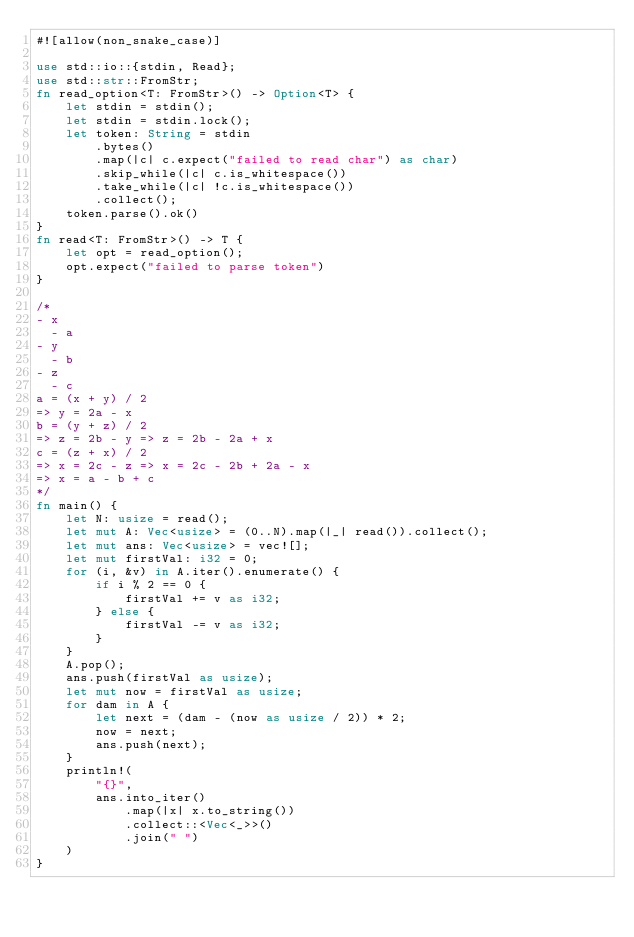<code> <loc_0><loc_0><loc_500><loc_500><_Rust_>#![allow(non_snake_case)]

use std::io::{stdin, Read};
use std::str::FromStr;
fn read_option<T: FromStr>() -> Option<T> {
    let stdin = stdin();
    let stdin = stdin.lock();
    let token: String = stdin
        .bytes()
        .map(|c| c.expect("failed to read char") as char)
        .skip_while(|c| c.is_whitespace())
        .take_while(|c| !c.is_whitespace())
        .collect();
    token.parse().ok()
}
fn read<T: FromStr>() -> T {
    let opt = read_option();
    opt.expect("failed to parse token")
}

/*
- x
  - a
- y
  - b
- z
  - c
a = (x + y) / 2
=> y = 2a - x
b = (y + z) / 2
=> z = 2b - y => z = 2b - 2a + x
c = (z + x) / 2
=> x = 2c - z => x = 2c - 2b + 2a - x
=> x = a - b + c
*/
fn main() {
    let N: usize = read();
    let mut A: Vec<usize> = (0..N).map(|_| read()).collect();
    let mut ans: Vec<usize> = vec![];
    let mut firstVal: i32 = 0;
    for (i, &v) in A.iter().enumerate() {
        if i % 2 == 0 {
            firstVal += v as i32;
        } else {
            firstVal -= v as i32;
        }
    }
    A.pop();
    ans.push(firstVal as usize);
    let mut now = firstVal as usize;
    for dam in A {
        let next = (dam - (now as usize / 2)) * 2;
        now = next;
        ans.push(next);
    }
    println!(
        "{}",
        ans.into_iter()
            .map(|x| x.to_string())
            .collect::<Vec<_>>()
            .join(" ")
    )
}
</code> 